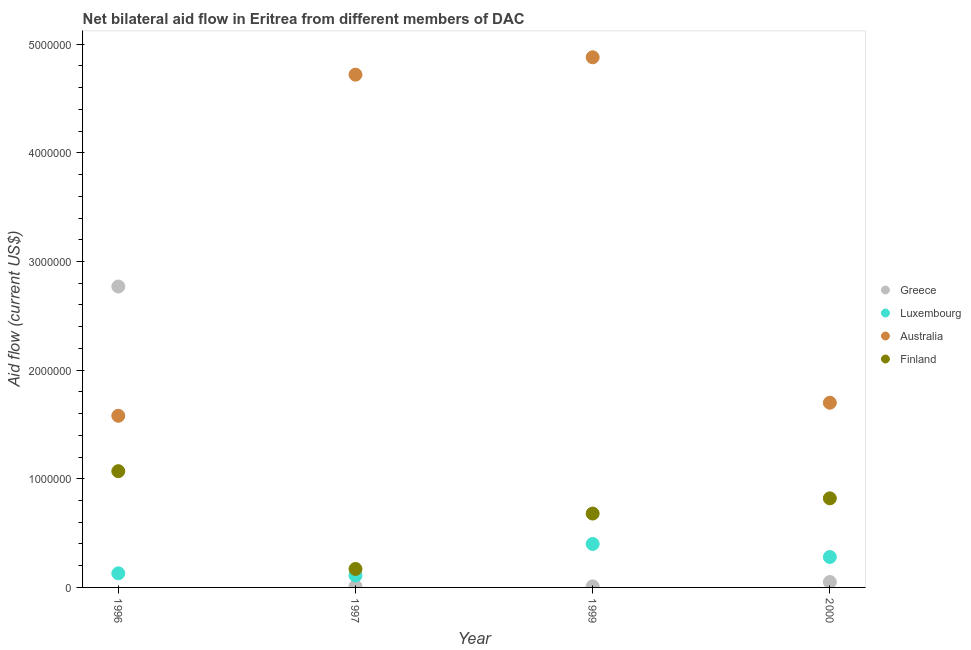Is the number of dotlines equal to the number of legend labels?
Give a very brief answer. Yes. What is the amount of aid given by finland in 1997?
Your answer should be compact. 1.70e+05. Across all years, what is the maximum amount of aid given by australia?
Offer a very short reply. 4.88e+06. Across all years, what is the minimum amount of aid given by australia?
Make the answer very short. 1.58e+06. In which year was the amount of aid given by australia maximum?
Keep it short and to the point. 1999. What is the total amount of aid given by australia in the graph?
Provide a short and direct response. 1.29e+07. What is the difference between the amount of aid given by finland in 1996 and that in 1997?
Your response must be concise. 9.00e+05. What is the difference between the amount of aid given by luxembourg in 1999 and the amount of aid given by greece in 2000?
Your response must be concise. 3.50e+05. What is the average amount of aid given by australia per year?
Ensure brevity in your answer.  3.22e+06. In the year 2000, what is the difference between the amount of aid given by luxembourg and amount of aid given by finland?
Offer a very short reply. -5.40e+05. What is the ratio of the amount of aid given by greece in 1996 to that in 1999?
Keep it short and to the point. 277. What is the difference between the highest and the lowest amount of aid given by luxembourg?
Your answer should be very brief. 2.90e+05. Is it the case that in every year, the sum of the amount of aid given by finland and amount of aid given by greece is greater than the sum of amount of aid given by australia and amount of aid given by luxembourg?
Your answer should be compact. No. Does the amount of aid given by greece monotonically increase over the years?
Ensure brevity in your answer.  No. Is the amount of aid given by greece strictly less than the amount of aid given by australia over the years?
Give a very brief answer. No. How many years are there in the graph?
Offer a terse response. 4. Are the values on the major ticks of Y-axis written in scientific E-notation?
Your answer should be very brief. No. Does the graph contain any zero values?
Your answer should be compact. No. Does the graph contain grids?
Offer a terse response. No. Where does the legend appear in the graph?
Offer a very short reply. Center right. What is the title of the graph?
Give a very brief answer. Net bilateral aid flow in Eritrea from different members of DAC. What is the label or title of the X-axis?
Your answer should be compact. Year. What is the Aid flow (current US$) in Greece in 1996?
Keep it short and to the point. 2.77e+06. What is the Aid flow (current US$) in Luxembourg in 1996?
Offer a very short reply. 1.30e+05. What is the Aid flow (current US$) in Australia in 1996?
Offer a terse response. 1.58e+06. What is the Aid flow (current US$) of Finland in 1996?
Make the answer very short. 1.07e+06. What is the Aid flow (current US$) of Greece in 1997?
Make the answer very short. 10000. What is the Aid flow (current US$) in Australia in 1997?
Your response must be concise. 4.72e+06. What is the Aid flow (current US$) in Greece in 1999?
Offer a terse response. 10000. What is the Aid flow (current US$) of Luxembourg in 1999?
Provide a short and direct response. 4.00e+05. What is the Aid flow (current US$) of Australia in 1999?
Provide a short and direct response. 4.88e+06. What is the Aid flow (current US$) of Finland in 1999?
Ensure brevity in your answer.  6.80e+05. What is the Aid flow (current US$) in Luxembourg in 2000?
Your answer should be very brief. 2.80e+05. What is the Aid flow (current US$) in Australia in 2000?
Ensure brevity in your answer.  1.70e+06. What is the Aid flow (current US$) in Finland in 2000?
Your response must be concise. 8.20e+05. Across all years, what is the maximum Aid flow (current US$) of Greece?
Offer a very short reply. 2.77e+06. Across all years, what is the maximum Aid flow (current US$) in Luxembourg?
Your answer should be compact. 4.00e+05. Across all years, what is the maximum Aid flow (current US$) in Australia?
Offer a terse response. 4.88e+06. Across all years, what is the maximum Aid flow (current US$) in Finland?
Give a very brief answer. 1.07e+06. Across all years, what is the minimum Aid flow (current US$) of Australia?
Provide a succinct answer. 1.58e+06. Across all years, what is the minimum Aid flow (current US$) of Finland?
Keep it short and to the point. 1.70e+05. What is the total Aid flow (current US$) in Greece in the graph?
Provide a succinct answer. 2.84e+06. What is the total Aid flow (current US$) of Luxembourg in the graph?
Offer a terse response. 9.20e+05. What is the total Aid flow (current US$) of Australia in the graph?
Your answer should be compact. 1.29e+07. What is the total Aid flow (current US$) of Finland in the graph?
Provide a short and direct response. 2.74e+06. What is the difference between the Aid flow (current US$) of Greece in 1996 and that in 1997?
Your answer should be very brief. 2.76e+06. What is the difference between the Aid flow (current US$) of Luxembourg in 1996 and that in 1997?
Your answer should be compact. 2.00e+04. What is the difference between the Aid flow (current US$) of Australia in 1996 and that in 1997?
Make the answer very short. -3.14e+06. What is the difference between the Aid flow (current US$) in Greece in 1996 and that in 1999?
Provide a short and direct response. 2.76e+06. What is the difference between the Aid flow (current US$) in Luxembourg in 1996 and that in 1999?
Your answer should be compact. -2.70e+05. What is the difference between the Aid flow (current US$) in Australia in 1996 and that in 1999?
Your answer should be very brief. -3.30e+06. What is the difference between the Aid flow (current US$) of Greece in 1996 and that in 2000?
Keep it short and to the point. 2.72e+06. What is the difference between the Aid flow (current US$) of Australia in 1996 and that in 2000?
Your answer should be very brief. -1.20e+05. What is the difference between the Aid flow (current US$) of Luxembourg in 1997 and that in 1999?
Give a very brief answer. -2.90e+05. What is the difference between the Aid flow (current US$) in Finland in 1997 and that in 1999?
Make the answer very short. -5.10e+05. What is the difference between the Aid flow (current US$) in Greece in 1997 and that in 2000?
Give a very brief answer. -4.00e+04. What is the difference between the Aid flow (current US$) in Australia in 1997 and that in 2000?
Keep it short and to the point. 3.02e+06. What is the difference between the Aid flow (current US$) in Finland in 1997 and that in 2000?
Keep it short and to the point. -6.50e+05. What is the difference between the Aid flow (current US$) in Greece in 1999 and that in 2000?
Make the answer very short. -4.00e+04. What is the difference between the Aid flow (current US$) in Australia in 1999 and that in 2000?
Provide a succinct answer. 3.18e+06. What is the difference between the Aid flow (current US$) in Finland in 1999 and that in 2000?
Your answer should be very brief. -1.40e+05. What is the difference between the Aid flow (current US$) in Greece in 1996 and the Aid flow (current US$) in Luxembourg in 1997?
Provide a succinct answer. 2.66e+06. What is the difference between the Aid flow (current US$) of Greece in 1996 and the Aid flow (current US$) of Australia in 1997?
Provide a short and direct response. -1.95e+06. What is the difference between the Aid flow (current US$) of Greece in 1996 and the Aid flow (current US$) of Finland in 1997?
Offer a very short reply. 2.60e+06. What is the difference between the Aid flow (current US$) in Luxembourg in 1996 and the Aid flow (current US$) in Australia in 1997?
Your response must be concise. -4.59e+06. What is the difference between the Aid flow (current US$) in Australia in 1996 and the Aid flow (current US$) in Finland in 1997?
Make the answer very short. 1.41e+06. What is the difference between the Aid flow (current US$) in Greece in 1996 and the Aid flow (current US$) in Luxembourg in 1999?
Keep it short and to the point. 2.37e+06. What is the difference between the Aid flow (current US$) of Greece in 1996 and the Aid flow (current US$) of Australia in 1999?
Ensure brevity in your answer.  -2.11e+06. What is the difference between the Aid flow (current US$) in Greece in 1996 and the Aid flow (current US$) in Finland in 1999?
Keep it short and to the point. 2.09e+06. What is the difference between the Aid flow (current US$) in Luxembourg in 1996 and the Aid flow (current US$) in Australia in 1999?
Your response must be concise. -4.75e+06. What is the difference between the Aid flow (current US$) in Luxembourg in 1996 and the Aid flow (current US$) in Finland in 1999?
Keep it short and to the point. -5.50e+05. What is the difference between the Aid flow (current US$) of Australia in 1996 and the Aid flow (current US$) of Finland in 1999?
Ensure brevity in your answer.  9.00e+05. What is the difference between the Aid flow (current US$) in Greece in 1996 and the Aid flow (current US$) in Luxembourg in 2000?
Your answer should be very brief. 2.49e+06. What is the difference between the Aid flow (current US$) of Greece in 1996 and the Aid flow (current US$) of Australia in 2000?
Give a very brief answer. 1.07e+06. What is the difference between the Aid flow (current US$) of Greece in 1996 and the Aid flow (current US$) of Finland in 2000?
Your answer should be compact. 1.95e+06. What is the difference between the Aid flow (current US$) of Luxembourg in 1996 and the Aid flow (current US$) of Australia in 2000?
Your answer should be very brief. -1.57e+06. What is the difference between the Aid flow (current US$) in Luxembourg in 1996 and the Aid flow (current US$) in Finland in 2000?
Your answer should be very brief. -6.90e+05. What is the difference between the Aid flow (current US$) of Australia in 1996 and the Aid flow (current US$) of Finland in 2000?
Your response must be concise. 7.60e+05. What is the difference between the Aid flow (current US$) in Greece in 1997 and the Aid flow (current US$) in Luxembourg in 1999?
Your answer should be very brief. -3.90e+05. What is the difference between the Aid flow (current US$) of Greece in 1997 and the Aid flow (current US$) of Australia in 1999?
Give a very brief answer. -4.87e+06. What is the difference between the Aid flow (current US$) in Greece in 1997 and the Aid flow (current US$) in Finland in 1999?
Give a very brief answer. -6.70e+05. What is the difference between the Aid flow (current US$) in Luxembourg in 1997 and the Aid flow (current US$) in Australia in 1999?
Ensure brevity in your answer.  -4.77e+06. What is the difference between the Aid flow (current US$) in Luxembourg in 1997 and the Aid flow (current US$) in Finland in 1999?
Keep it short and to the point. -5.70e+05. What is the difference between the Aid flow (current US$) of Australia in 1997 and the Aid flow (current US$) of Finland in 1999?
Ensure brevity in your answer.  4.04e+06. What is the difference between the Aid flow (current US$) in Greece in 1997 and the Aid flow (current US$) in Australia in 2000?
Offer a very short reply. -1.69e+06. What is the difference between the Aid flow (current US$) of Greece in 1997 and the Aid flow (current US$) of Finland in 2000?
Your response must be concise. -8.10e+05. What is the difference between the Aid flow (current US$) of Luxembourg in 1997 and the Aid flow (current US$) of Australia in 2000?
Your response must be concise. -1.59e+06. What is the difference between the Aid flow (current US$) in Luxembourg in 1997 and the Aid flow (current US$) in Finland in 2000?
Offer a terse response. -7.10e+05. What is the difference between the Aid flow (current US$) of Australia in 1997 and the Aid flow (current US$) of Finland in 2000?
Your answer should be very brief. 3.90e+06. What is the difference between the Aid flow (current US$) of Greece in 1999 and the Aid flow (current US$) of Australia in 2000?
Ensure brevity in your answer.  -1.69e+06. What is the difference between the Aid flow (current US$) of Greece in 1999 and the Aid flow (current US$) of Finland in 2000?
Keep it short and to the point. -8.10e+05. What is the difference between the Aid flow (current US$) of Luxembourg in 1999 and the Aid flow (current US$) of Australia in 2000?
Ensure brevity in your answer.  -1.30e+06. What is the difference between the Aid flow (current US$) in Luxembourg in 1999 and the Aid flow (current US$) in Finland in 2000?
Offer a very short reply. -4.20e+05. What is the difference between the Aid flow (current US$) of Australia in 1999 and the Aid flow (current US$) of Finland in 2000?
Make the answer very short. 4.06e+06. What is the average Aid flow (current US$) of Greece per year?
Offer a very short reply. 7.10e+05. What is the average Aid flow (current US$) of Australia per year?
Your answer should be very brief. 3.22e+06. What is the average Aid flow (current US$) in Finland per year?
Your answer should be compact. 6.85e+05. In the year 1996, what is the difference between the Aid flow (current US$) of Greece and Aid flow (current US$) of Luxembourg?
Ensure brevity in your answer.  2.64e+06. In the year 1996, what is the difference between the Aid flow (current US$) in Greece and Aid flow (current US$) in Australia?
Ensure brevity in your answer.  1.19e+06. In the year 1996, what is the difference between the Aid flow (current US$) of Greece and Aid flow (current US$) of Finland?
Provide a short and direct response. 1.70e+06. In the year 1996, what is the difference between the Aid flow (current US$) of Luxembourg and Aid flow (current US$) of Australia?
Your response must be concise. -1.45e+06. In the year 1996, what is the difference between the Aid flow (current US$) of Luxembourg and Aid flow (current US$) of Finland?
Make the answer very short. -9.40e+05. In the year 1996, what is the difference between the Aid flow (current US$) in Australia and Aid flow (current US$) in Finland?
Provide a short and direct response. 5.10e+05. In the year 1997, what is the difference between the Aid flow (current US$) of Greece and Aid flow (current US$) of Australia?
Offer a very short reply. -4.71e+06. In the year 1997, what is the difference between the Aid flow (current US$) in Greece and Aid flow (current US$) in Finland?
Your answer should be very brief. -1.60e+05. In the year 1997, what is the difference between the Aid flow (current US$) in Luxembourg and Aid flow (current US$) in Australia?
Provide a short and direct response. -4.61e+06. In the year 1997, what is the difference between the Aid flow (current US$) in Australia and Aid flow (current US$) in Finland?
Your answer should be compact. 4.55e+06. In the year 1999, what is the difference between the Aid flow (current US$) in Greece and Aid flow (current US$) in Luxembourg?
Offer a very short reply. -3.90e+05. In the year 1999, what is the difference between the Aid flow (current US$) of Greece and Aid flow (current US$) of Australia?
Provide a succinct answer. -4.87e+06. In the year 1999, what is the difference between the Aid flow (current US$) in Greece and Aid flow (current US$) in Finland?
Ensure brevity in your answer.  -6.70e+05. In the year 1999, what is the difference between the Aid flow (current US$) of Luxembourg and Aid flow (current US$) of Australia?
Ensure brevity in your answer.  -4.48e+06. In the year 1999, what is the difference between the Aid flow (current US$) of Luxembourg and Aid flow (current US$) of Finland?
Offer a very short reply. -2.80e+05. In the year 1999, what is the difference between the Aid flow (current US$) of Australia and Aid flow (current US$) of Finland?
Make the answer very short. 4.20e+06. In the year 2000, what is the difference between the Aid flow (current US$) of Greece and Aid flow (current US$) of Australia?
Ensure brevity in your answer.  -1.65e+06. In the year 2000, what is the difference between the Aid flow (current US$) in Greece and Aid flow (current US$) in Finland?
Provide a short and direct response. -7.70e+05. In the year 2000, what is the difference between the Aid flow (current US$) in Luxembourg and Aid flow (current US$) in Australia?
Your response must be concise. -1.42e+06. In the year 2000, what is the difference between the Aid flow (current US$) in Luxembourg and Aid flow (current US$) in Finland?
Keep it short and to the point. -5.40e+05. In the year 2000, what is the difference between the Aid flow (current US$) in Australia and Aid flow (current US$) in Finland?
Ensure brevity in your answer.  8.80e+05. What is the ratio of the Aid flow (current US$) in Greece in 1996 to that in 1997?
Your answer should be very brief. 277. What is the ratio of the Aid flow (current US$) in Luxembourg in 1996 to that in 1997?
Provide a short and direct response. 1.18. What is the ratio of the Aid flow (current US$) of Australia in 1996 to that in 1997?
Ensure brevity in your answer.  0.33. What is the ratio of the Aid flow (current US$) in Finland in 1996 to that in 1997?
Make the answer very short. 6.29. What is the ratio of the Aid flow (current US$) of Greece in 1996 to that in 1999?
Your answer should be very brief. 277. What is the ratio of the Aid flow (current US$) of Luxembourg in 1996 to that in 1999?
Provide a short and direct response. 0.33. What is the ratio of the Aid flow (current US$) of Australia in 1996 to that in 1999?
Your response must be concise. 0.32. What is the ratio of the Aid flow (current US$) in Finland in 1996 to that in 1999?
Provide a short and direct response. 1.57. What is the ratio of the Aid flow (current US$) of Greece in 1996 to that in 2000?
Provide a succinct answer. 55.4. What is the ratio of the Aid flow (current US$) in Luxembourg in 1996 to that in 2000?
Give a very brief answer. 0.46. What is the ratio of the Aid flow (current US$) in Australia in 1996 to that in 2000?
Provide a succinct answer. 0.93. What is the ratio of the Aid flow (current US$) in Finland in 1996 to that in 2000?
Ensure brevity in your answer.  1.3. What is the ratio of the Aid flow (current US$) in Luxembourg in 1997 to that in 1999?
Provide a succinct answer. 0.28. What is the ratio of the Aid flow (current US$) in Australia in 1997 to that in 1999?
Provide a succinct answer. 0.97. What is the ratio of the Aid flow (current US$) in Finland in 1997 to that in 1999?
Provide a succinct answer. 0.25. What is the ratio of the Aid flow (current US$) of Luxembourg in 1997 to that in 2000?
Your response must be concise. 0.39. What is the ratio of the Aid flow (current US$) of Australia in 1997 to that in 2000?
Offer a terse response. 2.78. What is the ratio of the Aid flow (current US$) in Finland in 1997 to that in 2000?
Ensure brevity in your answer.  0.21. What is the ratio of the Aid flow (current US$) in Greece in 1999 to that in 2000?
Give a very brief answer. 0.2. What is the ratio of the Aid flow (current US$) in Luxembourg in 1999 to that in 2000?
Ensure brevity in your answer.  1.43. What is the ratio of the Aid flow (current US$) in Australia in 1999 to that in 2000?
Provide a short and direct response. 2.87. What is the ratio of the Aid flow (current US$) in Finland in 1999 to that in 2000?
Give a very brief answer. 0.83. What is the difference between the highest and the second highest Aid flow (current US$) of Greece?
Make the answer very short. 2.72e+06. What is the difference between the highest and the second highest Aid flow (current US$) of Luxembourg?
Ensure brevity in your answer.  1.20e+05. What is the difference between the highest and the lowest Aid flow (current US$) of Greece?
Offer a terse response. 2.76e+06. What is the difference between the highest and the lowest Aid flow (current US$) in Luxembourg?
Ensure brevity in your answer.  2.90e+05. What is the difference between the highest and the lowest Aid flow (current US$) of Australia?
Your response must be concise. 3.30e+06. What is the difference between the highest and the lowest Aid flow (current US$) of Finland?
Your answer should be very brief. 9.00e+05. 